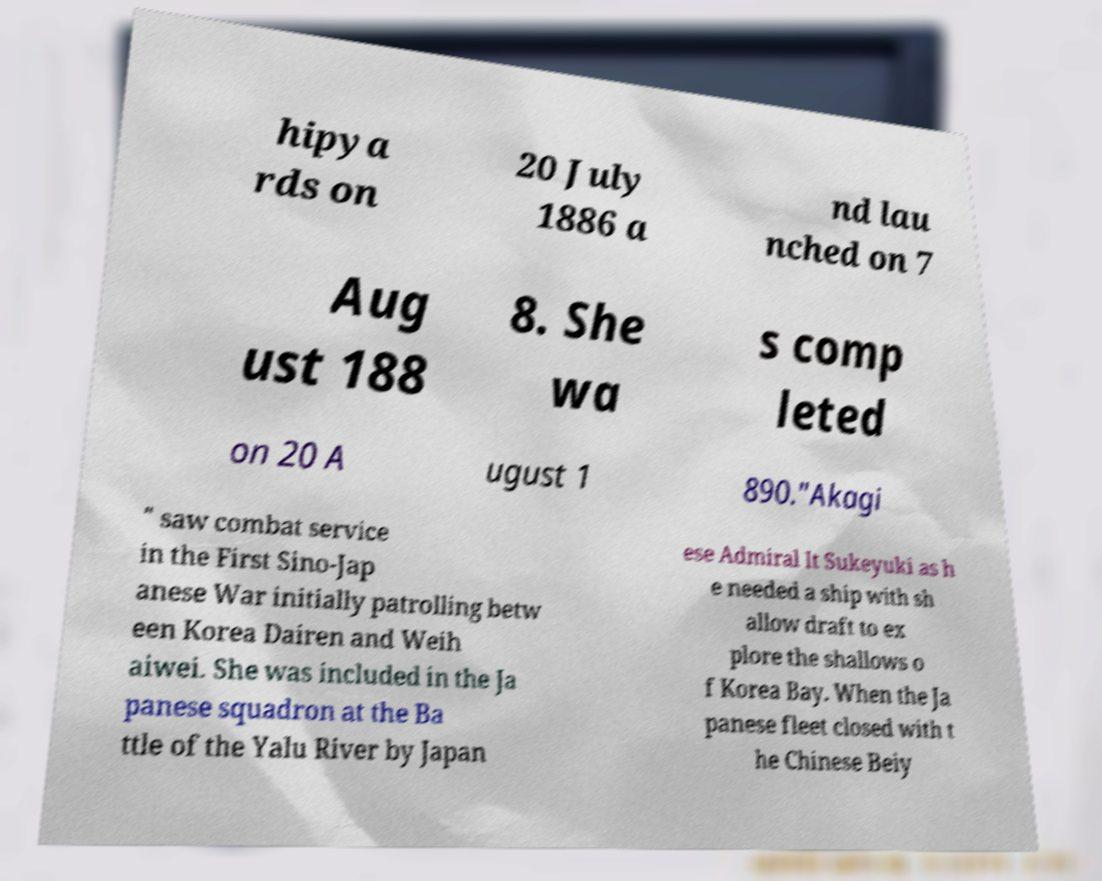Can you accurately transcribe the text from the provided image for me? hipya rds on 20 July 1886 a nd lau nched on 7 Aug ust 188 8. She wa s comp leted on 20 A ugust 1 890."Akagi " saw combat service in the First Sino-Jap anese War initially patrolling betw een Korea Dairen and Weih aiwei. She was included in the Ja panese squadron at the Ba ttle of the Yalu River by Japan ese Admiral It Sukeyuki as h e needed a ship with sh allow draft to ex plore the shallows o f Korea Bay. When the Ja panese fleet closed with t he Chinese Beiy 